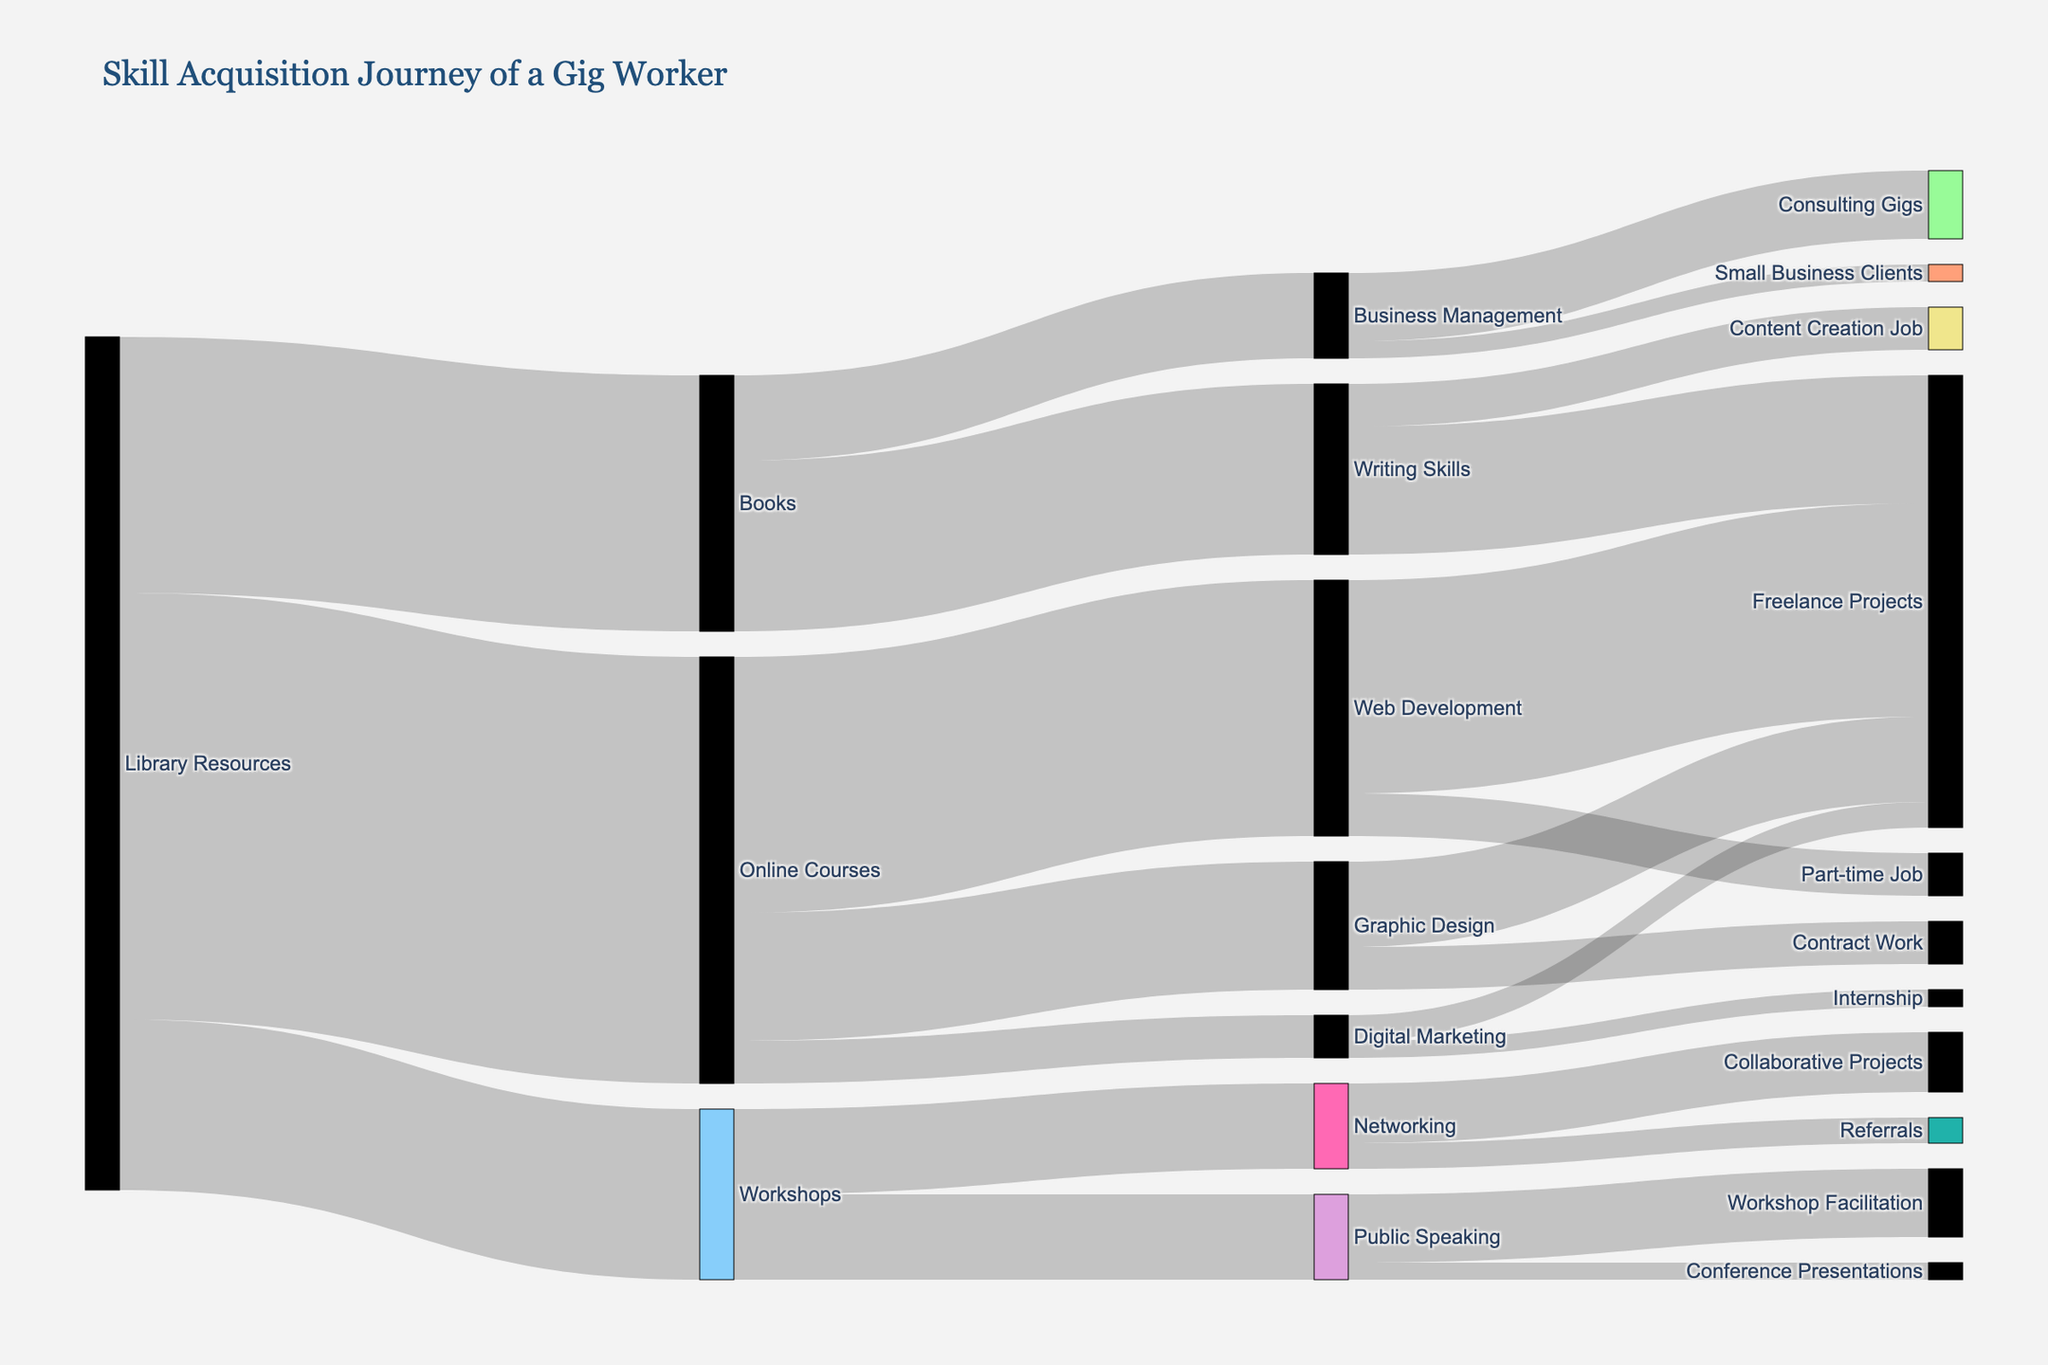What is the title of the Sankey diagram? The title of the diagram is typically displayed at the top center of the figure in a larger font size. It summarizes the main topic of the visual representation. In this case, the title helps the viewer understand what the entire diagram is about—namely, the skill acquisition journey.
Answer: "Skill Acquisition Journey of a Gig Worker" How many resources are depicted as starting points in the Sankey diagram? By looking at the lefthand side of the diagram, you can identify the initial nodes which are the starting points for the flows. The diagram starts with Library Resources, Online Courses, Books, and Workshops.
Answer: 4 From the Library Resources, which category receives the highest amount of investment? To answer this, trace the path from Library Resources to each of its target nodes (Online Courses, Books, Workshops) and compare the values associated with each link. The highest value will indicate the category with the most investment.
Answer: Online Courses How many different job opportunities stem from Web Development skills? Look at the flows that continue from the Web Development node to identify all the resulting job opportunities. Count each unique node that Web Development leads to.
Answer: 2 Summing up all resources, how many total units of investment are there? Add together all the values connected to the initial resource nodes: Library Resources (50 + 30 + 20), Online Courses (30 + 15 + 5), Books (20 + 10), and Workshops (10 + 10).
Answer: 170 Which skill acquired through Books results in the highest number of job opportunities? Analyze the values connected from the Books node to its resultant job skills (Writing Skills and Business Management) to determine the highest value. Writing Skills lead to a higher number based on the associated values.
Answer: Writing Skills What is the total value of freelance projects resulting from various skills? Identify and sum the values for all paths that lead to the Freelance Projects node: Web Development (25), Graphic Design (10), Digital Marketing (3), and Writing Skills (15).
Answer: 53 Between Digital Marketing and Graphic Design, which one leads to more types of job opportunities? Look at the target nodes from Digital Marketing and Graphic Design, then count the number of unique job nodes for each skill category.
Answer: Graphic Design How does the investment into Networking through Workshops compare to Public Speaking through Workshops? Check the values leading from Workshops to Networking and Public Speaking, then compare these two values.
Answer: They are equal Which resource has the smallest amount of investment? Look at the initial investments from the various resource nodes and identify the one with the smallest value.
Answer: Workshops 